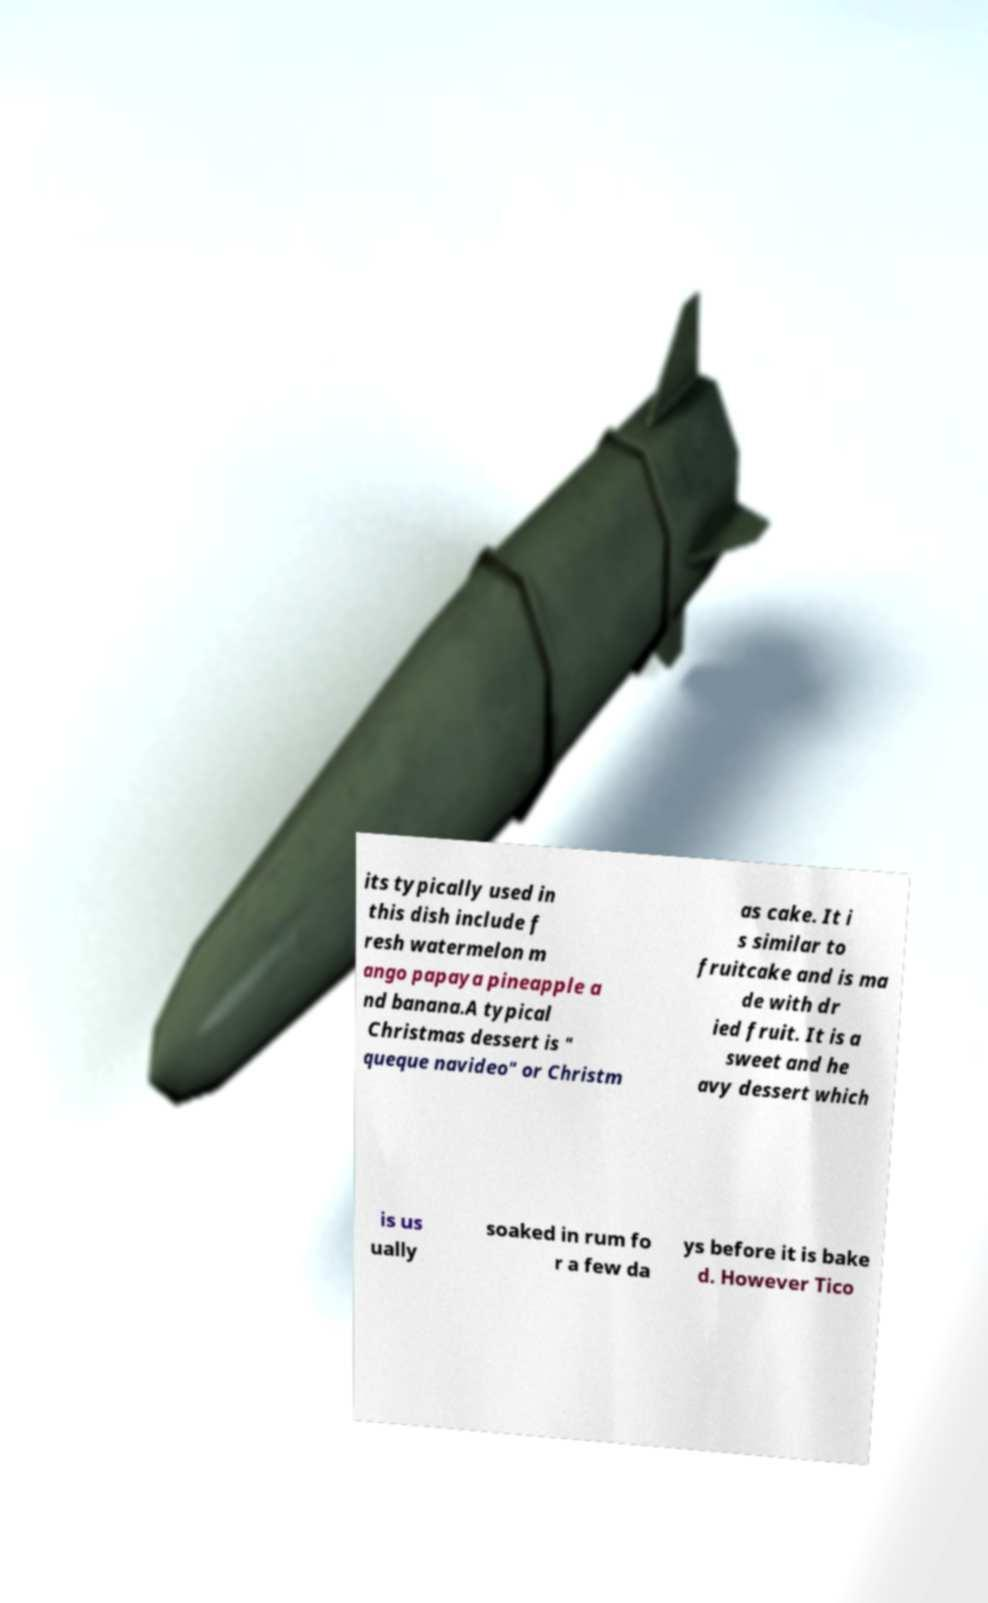Please read and relay the text visible in this image. What does it say? its typically used in this dish include f resh watermelon m ango papaya pineapple a nd banana.A typical Christmas dessert is " queque navideo" or Christm as cake. It i s similar to fruitcake and is ma de with dr ied fruit. It is a sweet and he avy dessert which is us ually soaked in rum fo r a few da ys before it is bake d. However Tico 